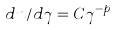<formula> <loc_0><loc_0><loc_500><loc_500>d n / d \gamma = C \gamma ^ { - p }</formula> 